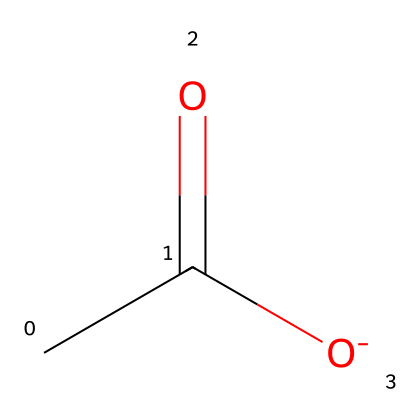What is the common name for the structure represented? The structure CC(=O)[O-] is commonly known as acetate, derived from acetic acid after deprotonation.
Answer: acetate How many oxygen atoms are present in the structure? The SMILES representation shows two oxygen atoms: one in the carboxylate group (–O-) and another in the carbonyl group (C=O).
Answer: two What type of functional group is present in this molecule? The presence of the –COO- group indicates that this molecule contains a carboxylate functional group.
Answer: carboxylate How many carbon atoms are in the structure? The representation CC(=O)[O-] indicates one carbon atom from the acetyl part, making it a total of two carbon atoms.
Answer: two Is acetate a saturated or unsaturated compound? Acetate, having no double bonds in the carbon chain (aside from the carbonyl), is classified as a saturated compound.
Answer: saturated In the context of lipids, what role does acetate play? Acetate serves as a building block for the synthesis of fatty acids, which are essential components of lipids.
Answer: building block 